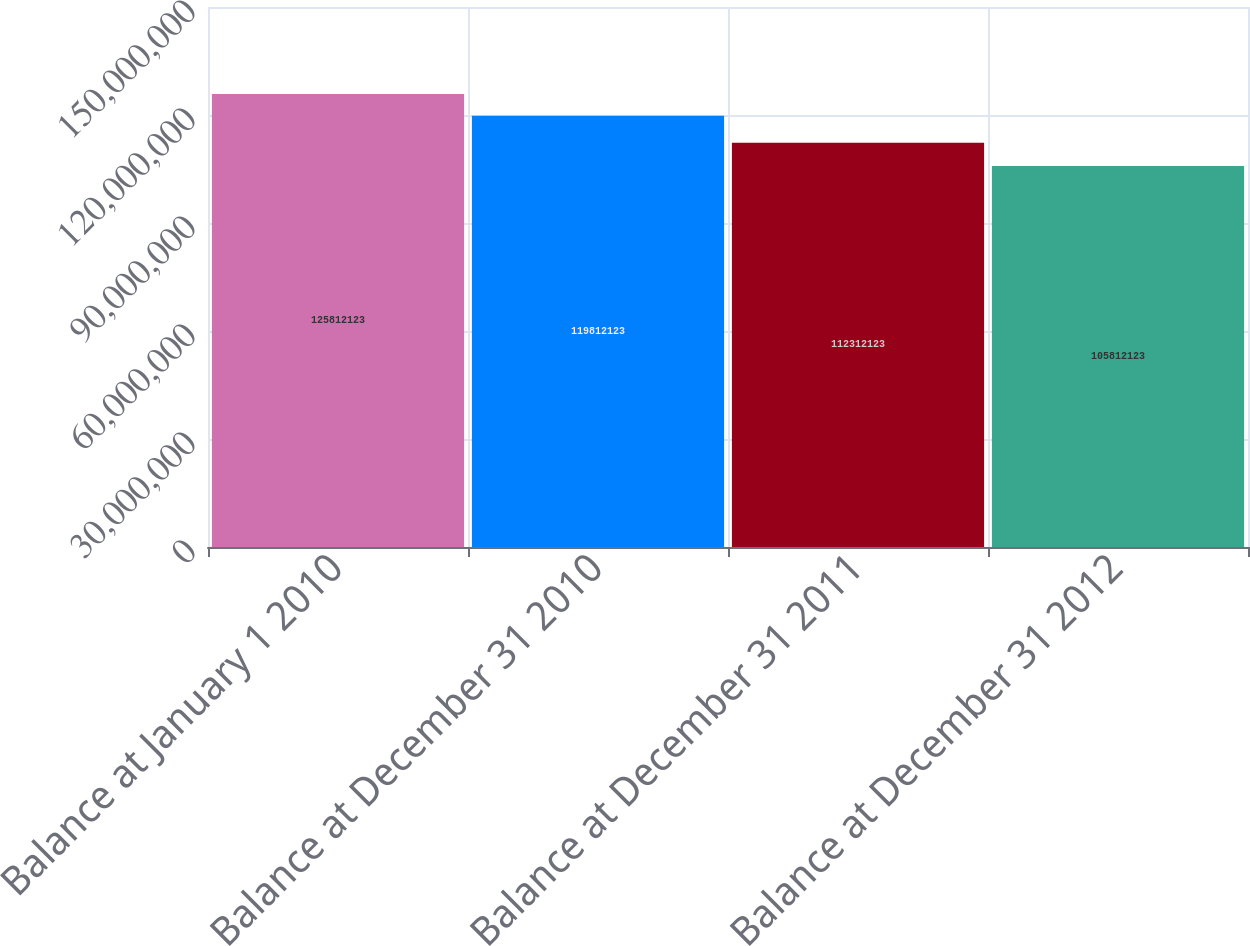Convert chart to OTSL. <chart><loc_0><loc_0><loc_500><loc_500><bar_chart><fcel>Balance at January 1 2010<fcel>Balance at December 31 2010<fcel>Balance at December 31 2011<fcel>Balance at December 31 2012<nl><fcel>1.25812e+08<fcel>1.19812e+08<fcel>1.12312e+08<fcel>1.05812e+08<nl></chart> 